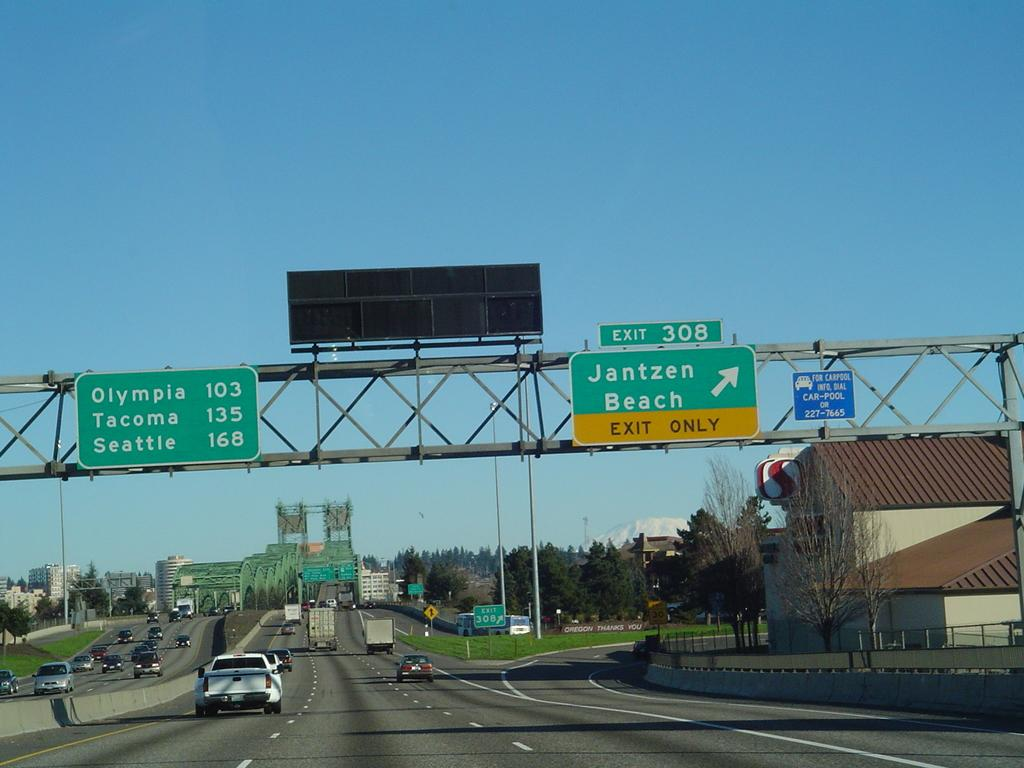<image>
Relay a brief, clear account of the picture shown. A road scene showing a sign that says Jantzen Beach Exit Only. 